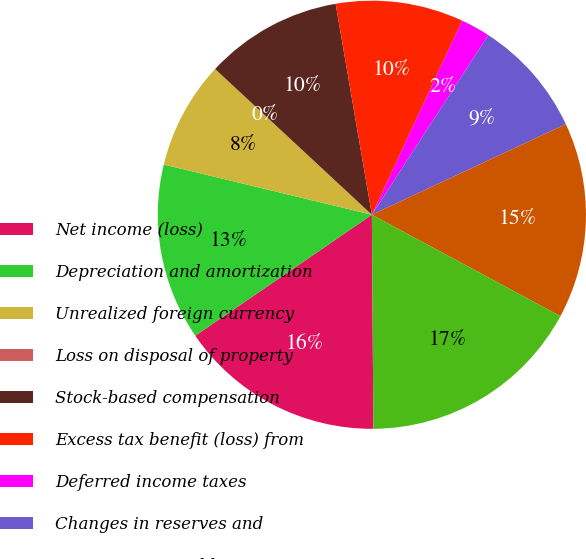Convert chart. <chart><loc_0><loc_0><loc_500><loc_500><pie_chart><fcel>Net income (loss)<fcel>Depreciation and amortization<fcel>Unrealized foreign currency<fcel>Loss on disposal of property<fcel>Stock-based compensation<fcel>Excess tax benefit (loss) from<fcel>Deferred income taxes<fcel>Changes in reserves and<fcel>Accounts receivable<fcel>Inventories<nl><fcel>15.55%<fcel>13.33%<fcel>8.15%<fcel>0.0%<fcel>10.37%<fcel>9.63%<fcel>2.23%<fcel>8.89%<fcel>14.81%<fcel>17.03%<nl></chart> 